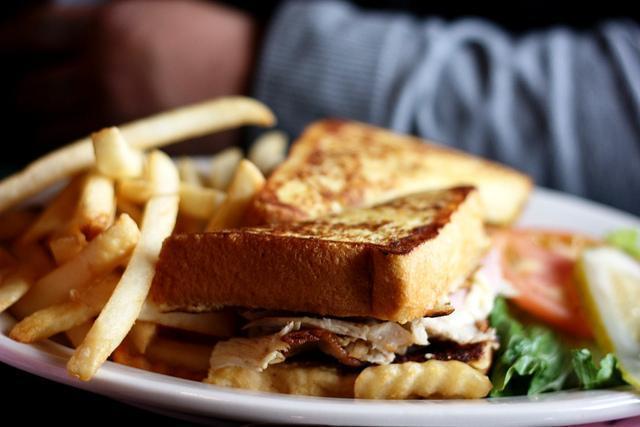What commonly goes on the long light yellow food here?
Pick the correct solution from the four options below to address the question.
Options: Soy sauce, wasabi, ketchup, oyster sauce. Ketchup. 